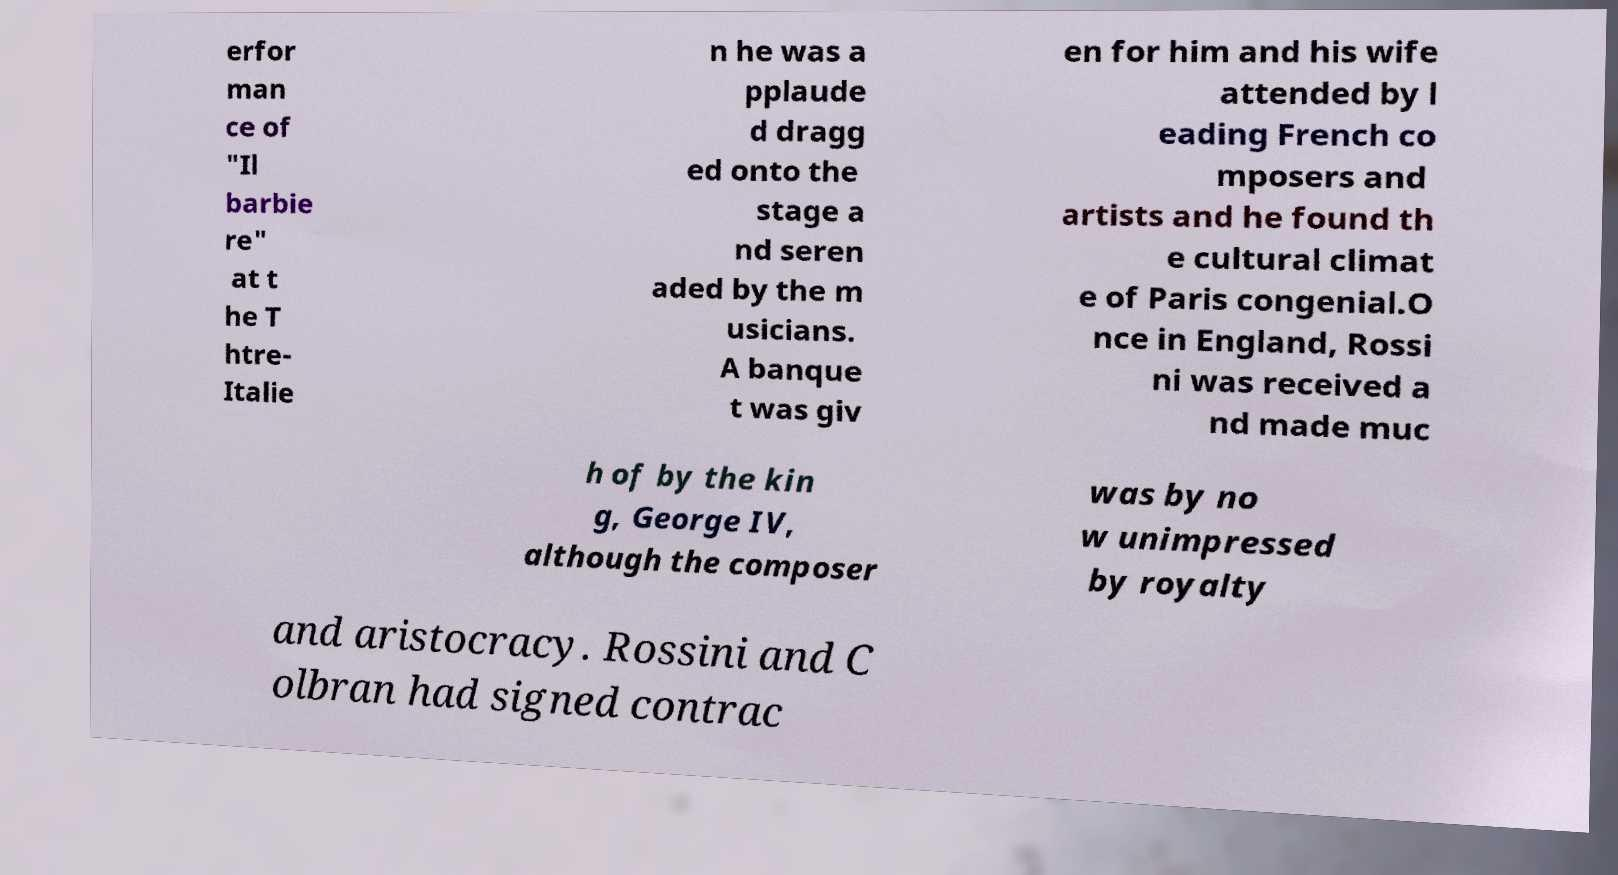There's text embedded in this image that I need extracted. Can you transcribe it verbatim? erfor man ce of "Il barbie re" at t he T htre- Italie n he was a pplaude d dragg ed onto the stage a nd seren aded by the m usicians. A banque t was giv en for him and his wife attended by l eading French co mposers and artists and he found th e cultural climat e of Paris congenial.O nce in England, Rossi ni was received a nd made muc h of by the kin g, George IV, although the composer was by no w unimpressed by royalty and aristocracy. Rossini and C olbran had signed contrac 